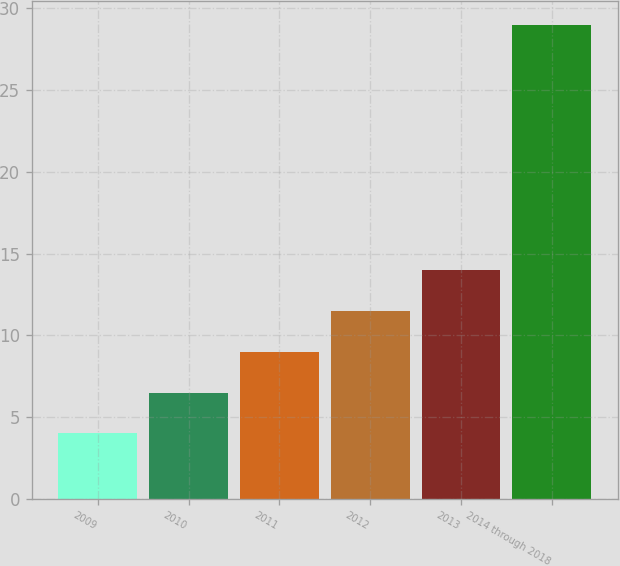Convert chart to OTSL. <chart><loc_0><loc_0><loc_500><loc_500><bar_chart><fcel>2009<fcel>2010<fcel>2011<fcel>2012<fcel>2013<fcel>2014 through 2018<nl><fcel>4<fcel>6.5<fcel>9<fcel>11.5<fcel>14<fcel>29<nl></chart> 